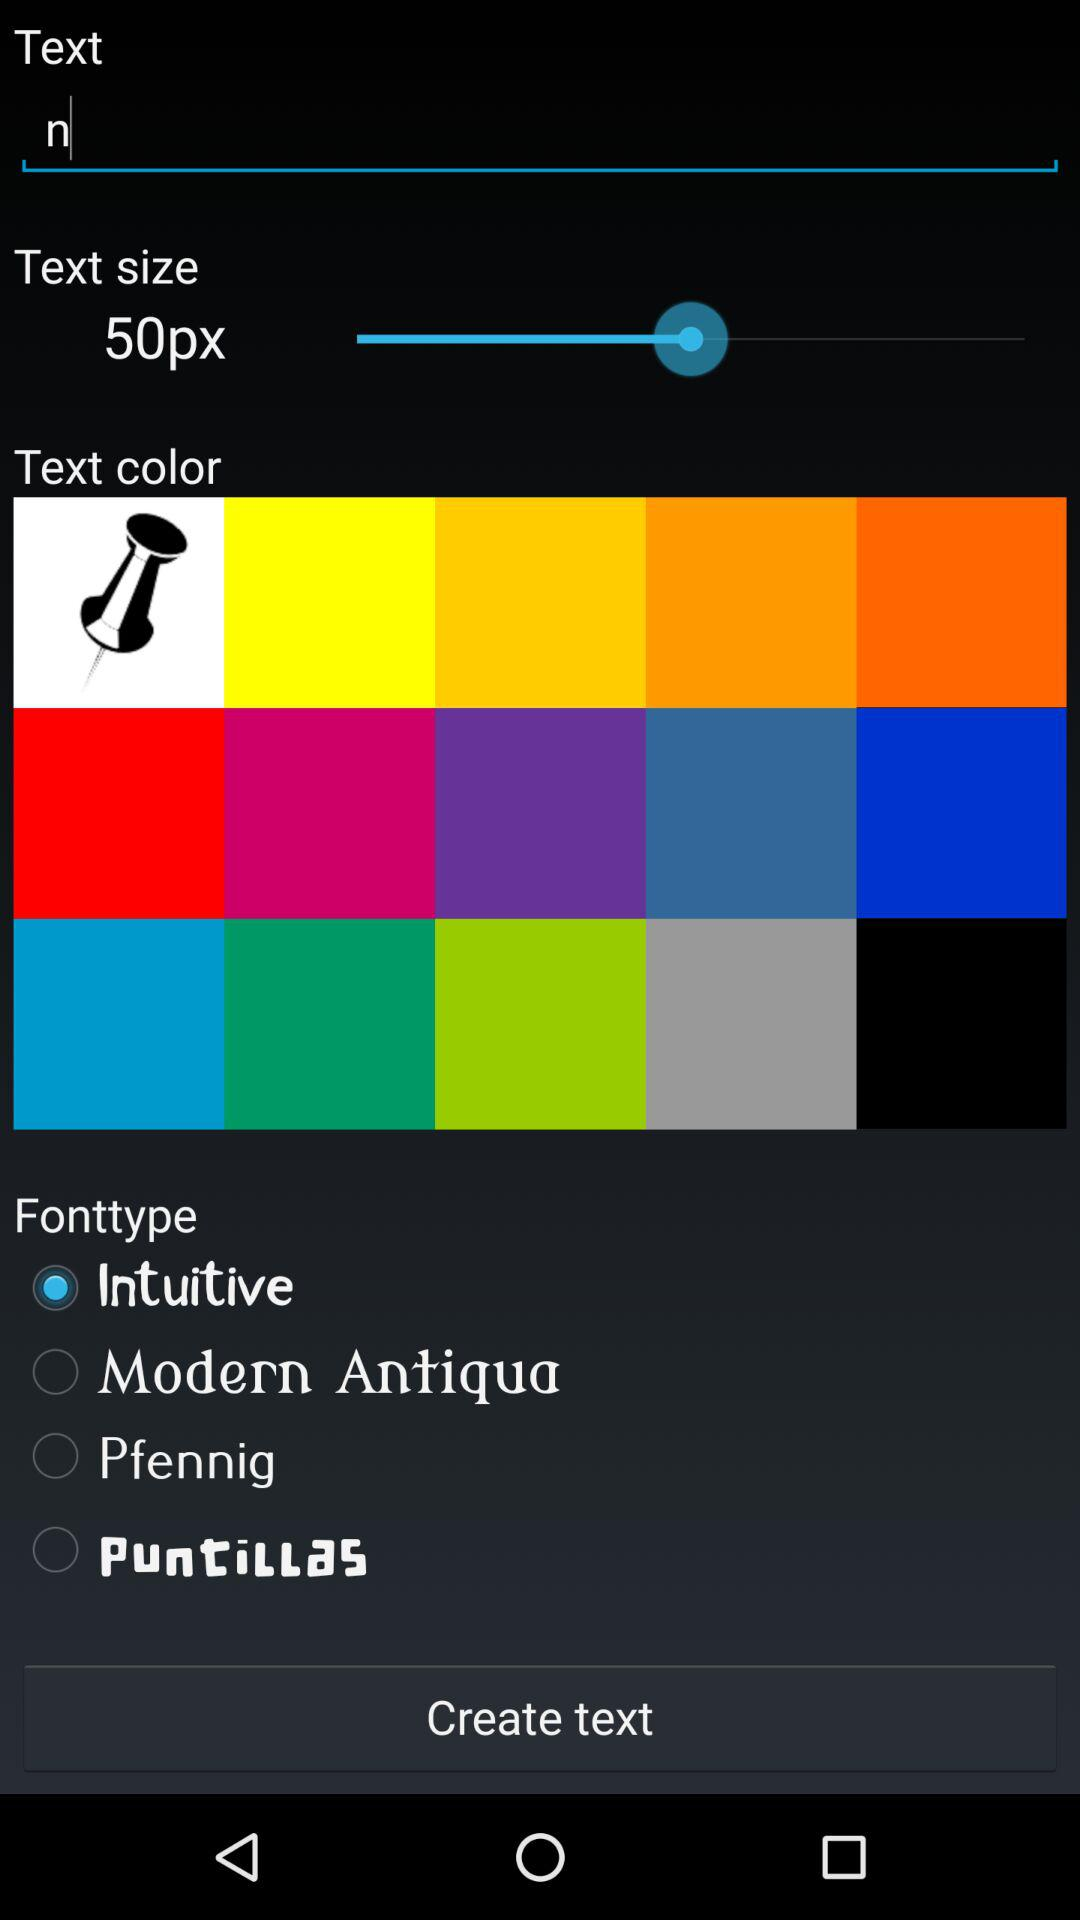What is the text entered on the screen? The text is n. 